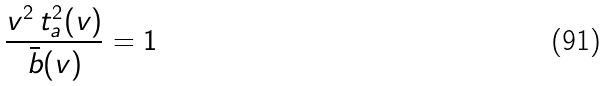<formula> <loc_0><loc_0><loc_500><loc_500>\frac { v ^ { 2 } \, t _ { a } ^ { 2 } ( v ) } { \bar { b } ( v ) } = 1</formula> 